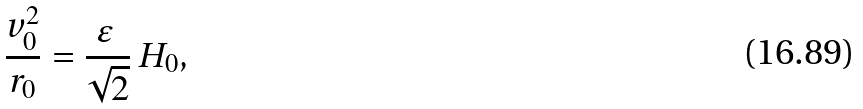Convert formula to latex. <formula><loc_0><loc_0><loc_500><loc_500>\frac { v _ { 0 } ^ { 2 } } { r _ { 0 } } = \frac { \varepsilon \, } { \sqrt { 2 } } \, H _ { 0 } ,</formula> 